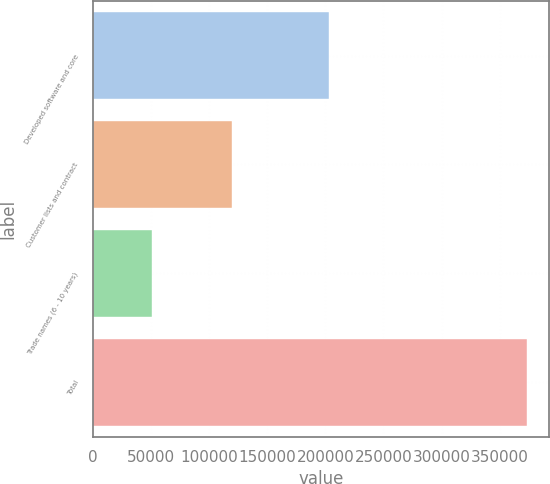<chart> <loc_0><loc_0><loc_500><loc_500><bar_chart><fcel>Developed software and core<fcel>Customer lists and contract<fcel>Trade names (6 - 10 years)<fcel>Total<nl><fcel>203236<fcel>119368<fcel>50990<fcel>373594<nl></chart> 